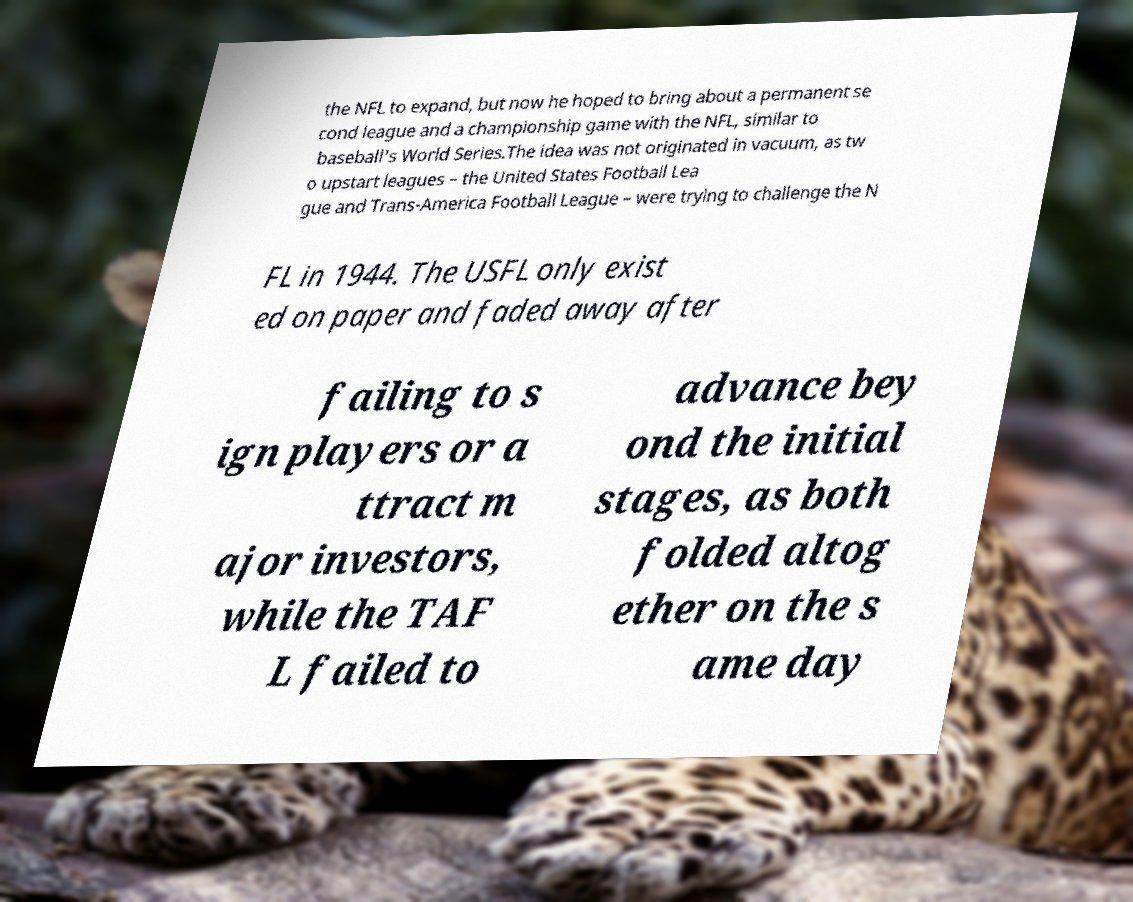Please read and relay the text visible in this image. What does it say? the NFL to expand, but now he hoped to bring about a permanent se cond league and a championship game with the NFL, similar to baseball's World Series.The idea was not originated in vacuum, as tw o upstart leagues – the United States Football Lea gue and Trans-America Football League – were trying to challenge the N FL in 1944. The USFL only exist ed on paper and faded away after failing to s ign players or a ttract m ajor investors, while the TAF L failed to advance bey ond the initial stages, as both folded altog ether on the s ame day 